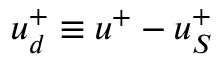Convert formula to latex. <formula><loc_0><loc_0><loc_500><loc_500>u _ { d } ^ { + } \equiv u ^ { + } - u _ { S } ^ { + }</formula> 